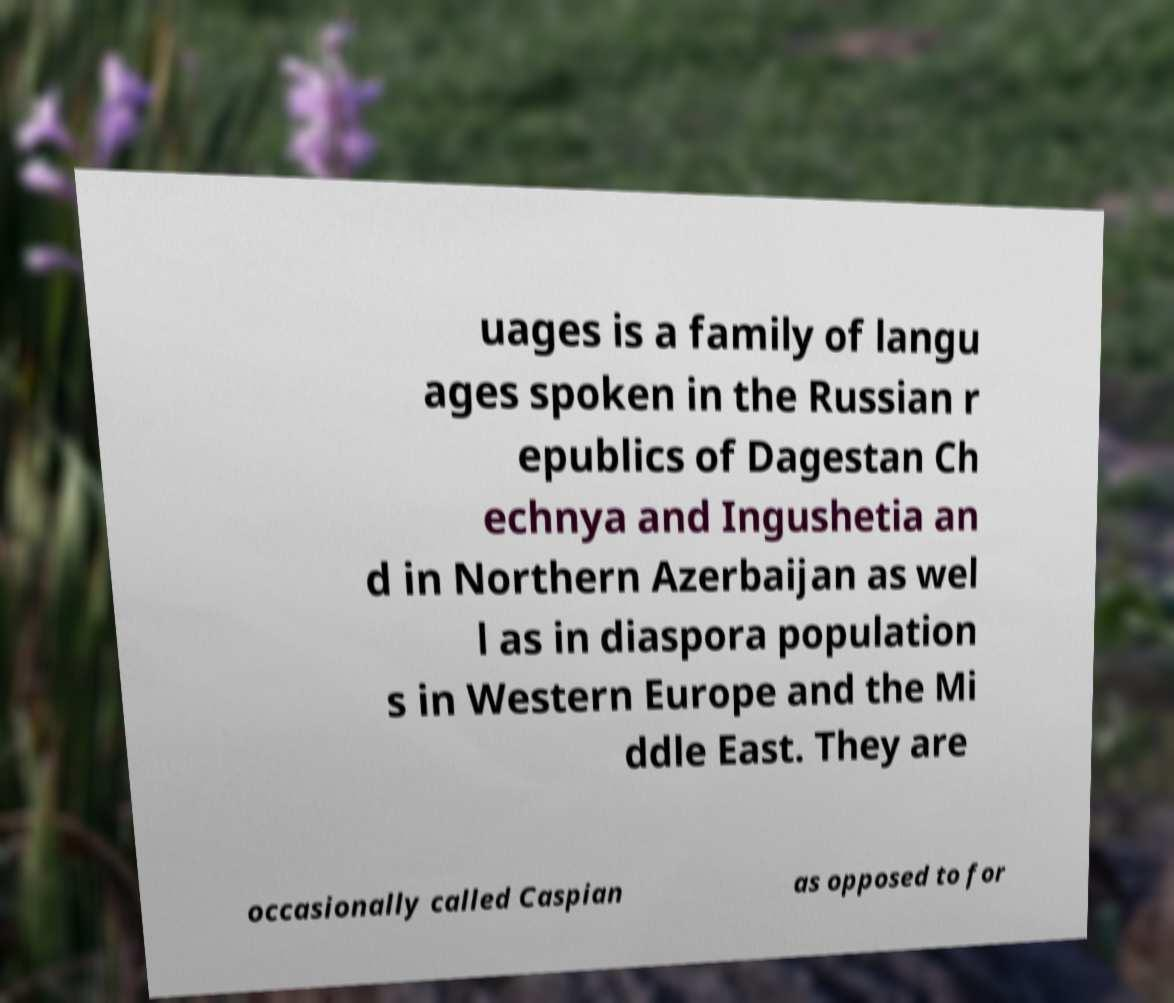Can you accurately transcribe the text from the provided image for me? uages is a family of langu ages spoken in the Russian r epublics of Dagestan Ch echnya and Ingushetia an d in Northern Azerbaijan as wel l as in diaspora population s in Western Europe and the Mi ddle East. They are occasionally called Caspian as opposed to for 